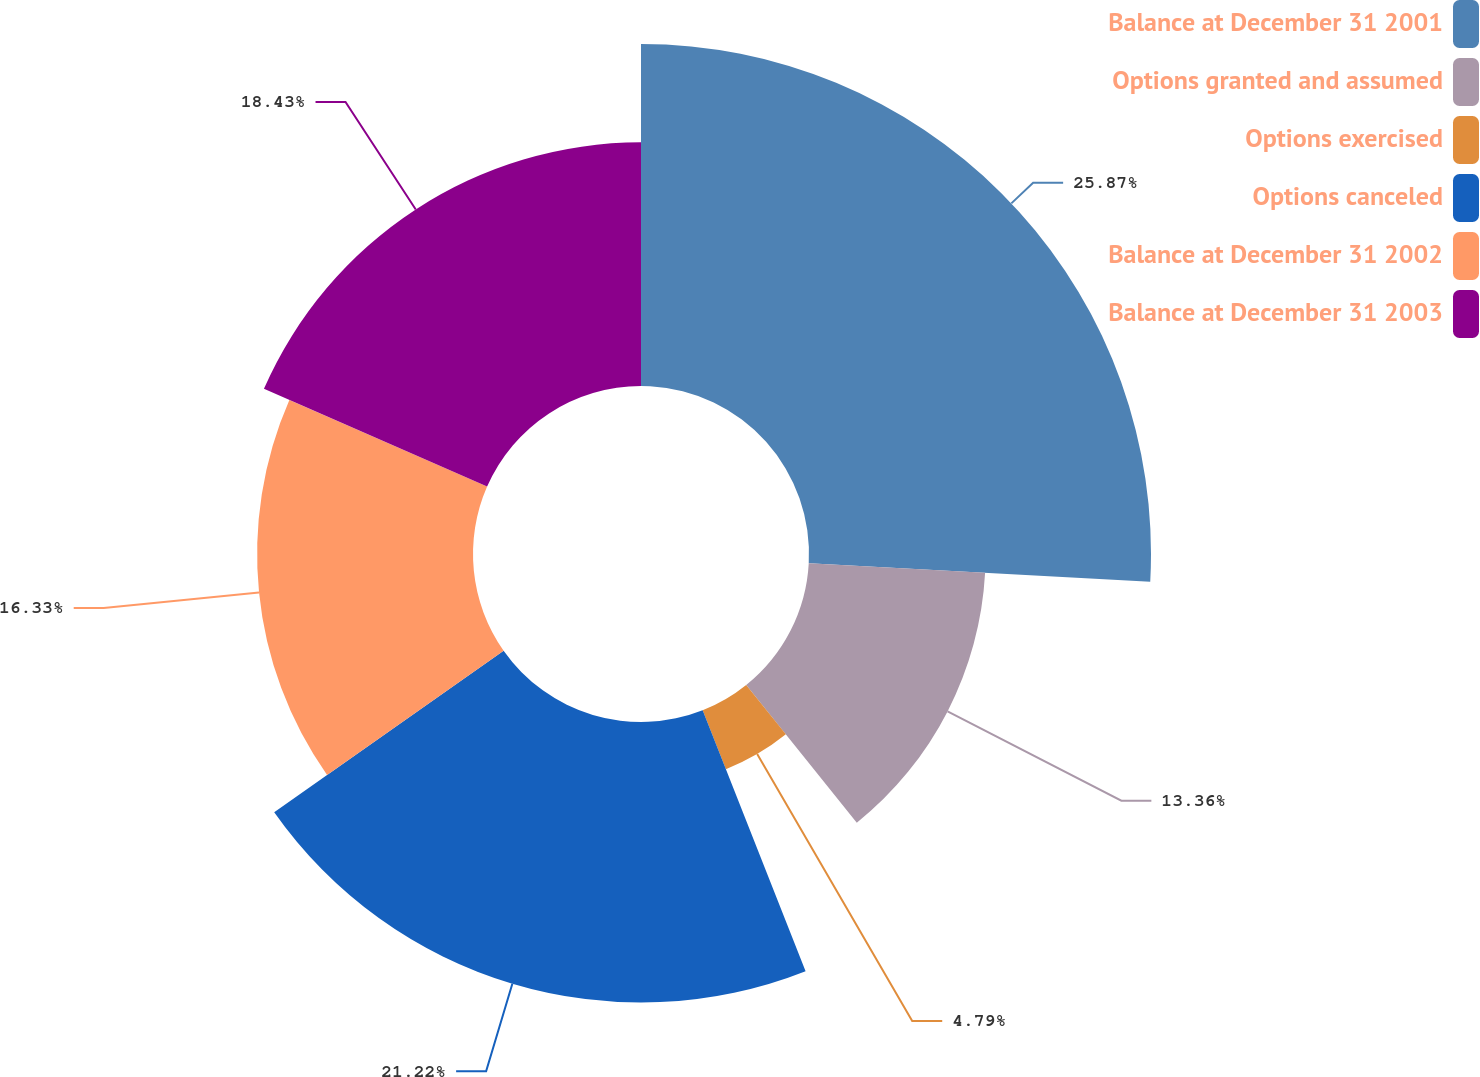Convert chart to OTSL. <chart><loc_0><loc_0><loc_500><loc_500><pie_chart><fcel>Balance at December 31 2001<fcel>Options granted and assumed<fcel>Options exercised<fcel>Options canceled<fcel>Balance at December 31 2002<fcel>Balance at December 31 2003<nl><fcel>25.87%<fcel>13.36%<fcel>4.79%<fcel>21.22%<fcel>16.33%<fcel>18.43%<nl></chart> 